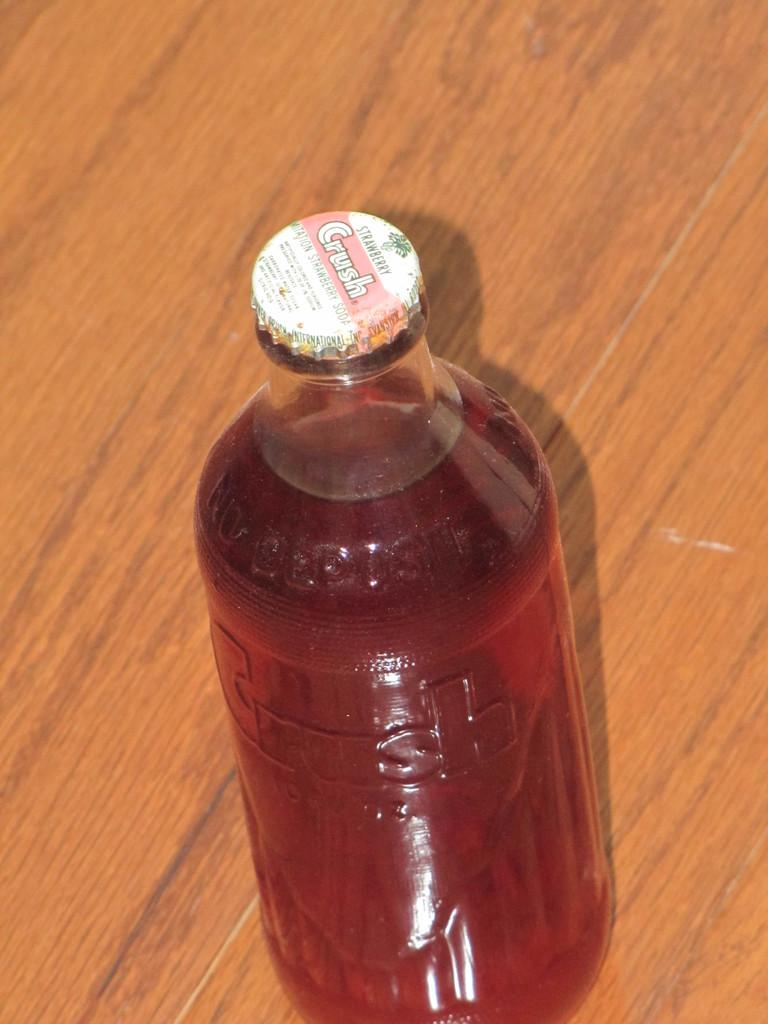<image>
Create a compact narrative representing the image presented. a bottle of Crush Strawberry on a wood table 